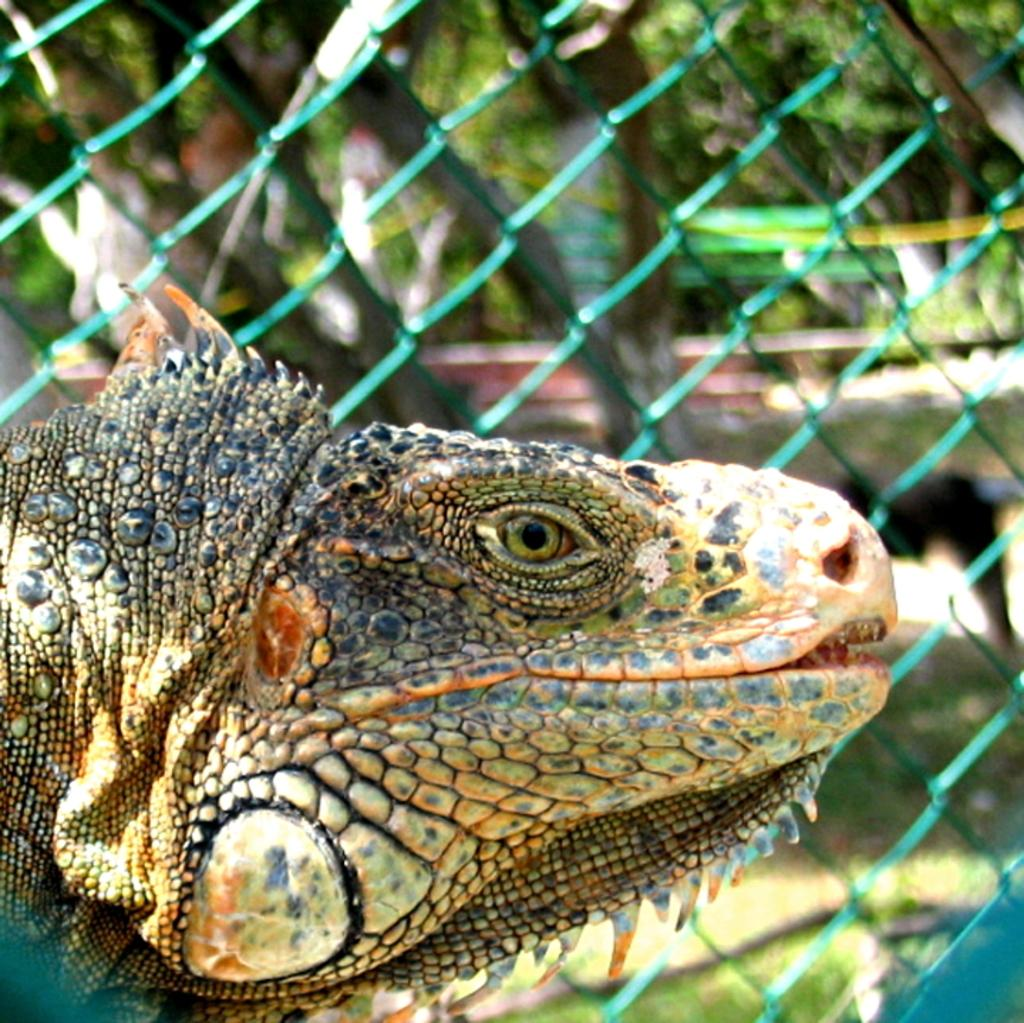What animal is present in the image? There is a crocodile in the image. What can be seen in the background of the image? There is a net fence and trees in the background of the image. What type of paper is the crocodile using to express its anger in the image? There is no paper or expression of anger present in the image; it simply features a crocodile and a background with a net fence and trees. 